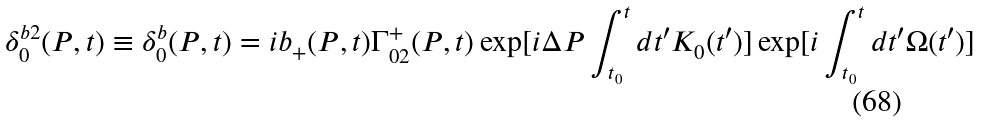Convert formula to latex. <formula><loc_0><loc_0><loc_500><loc_500>\delta _ { 0 } ^ { b 2 } ( P , t ) \equiv \delta _ { 0 } ^ { b } ( P , t ) = i b _ { + } ( P , t ) \Gamma _ { 0 2 } ^ { + } ( P , t ) \exp [ i \Delta P \int _ { t _ { 0 } } ^ { t } d t ^ { \prime } K _ { 0 } ( t ^ { \prime } ) ] \exp [ i \int _ { t _ { 0 } } ^ { t } d t ^ { \prime } \Omega ( t ^ { \prime } ) ]</formula> 